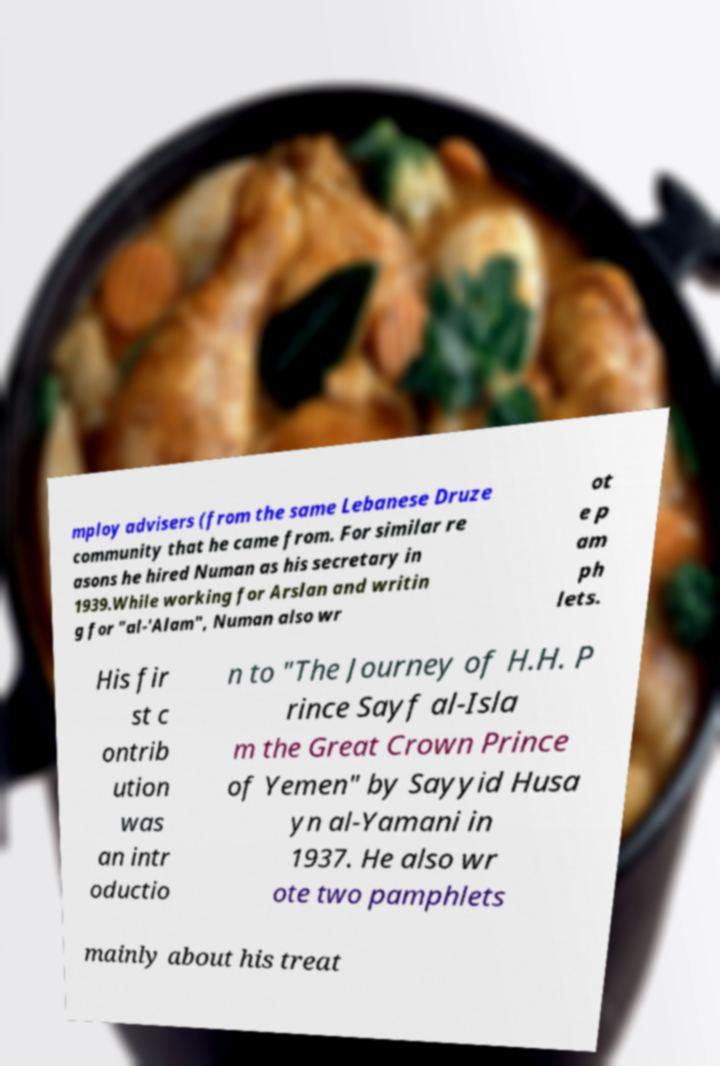I need the written content from this picture converted into text. Can you do that? mploy advisers (from the same Lebanese Druze community that he came from. For similar re asons he hired Numan as his secretary in 1939.While working for Arslan and writin g for "al-'Alam", Numan also wr ot e p am ph lets. His fir st c ontrib ution was an intr oductio n to "The Journey of H.H. P rince Sayf al-Isla m the Great Crown Prince of Yemen" by Sayyid Husa yn al-Yamani in 1937. He also wr ote two pamphlets mainly about his treat 